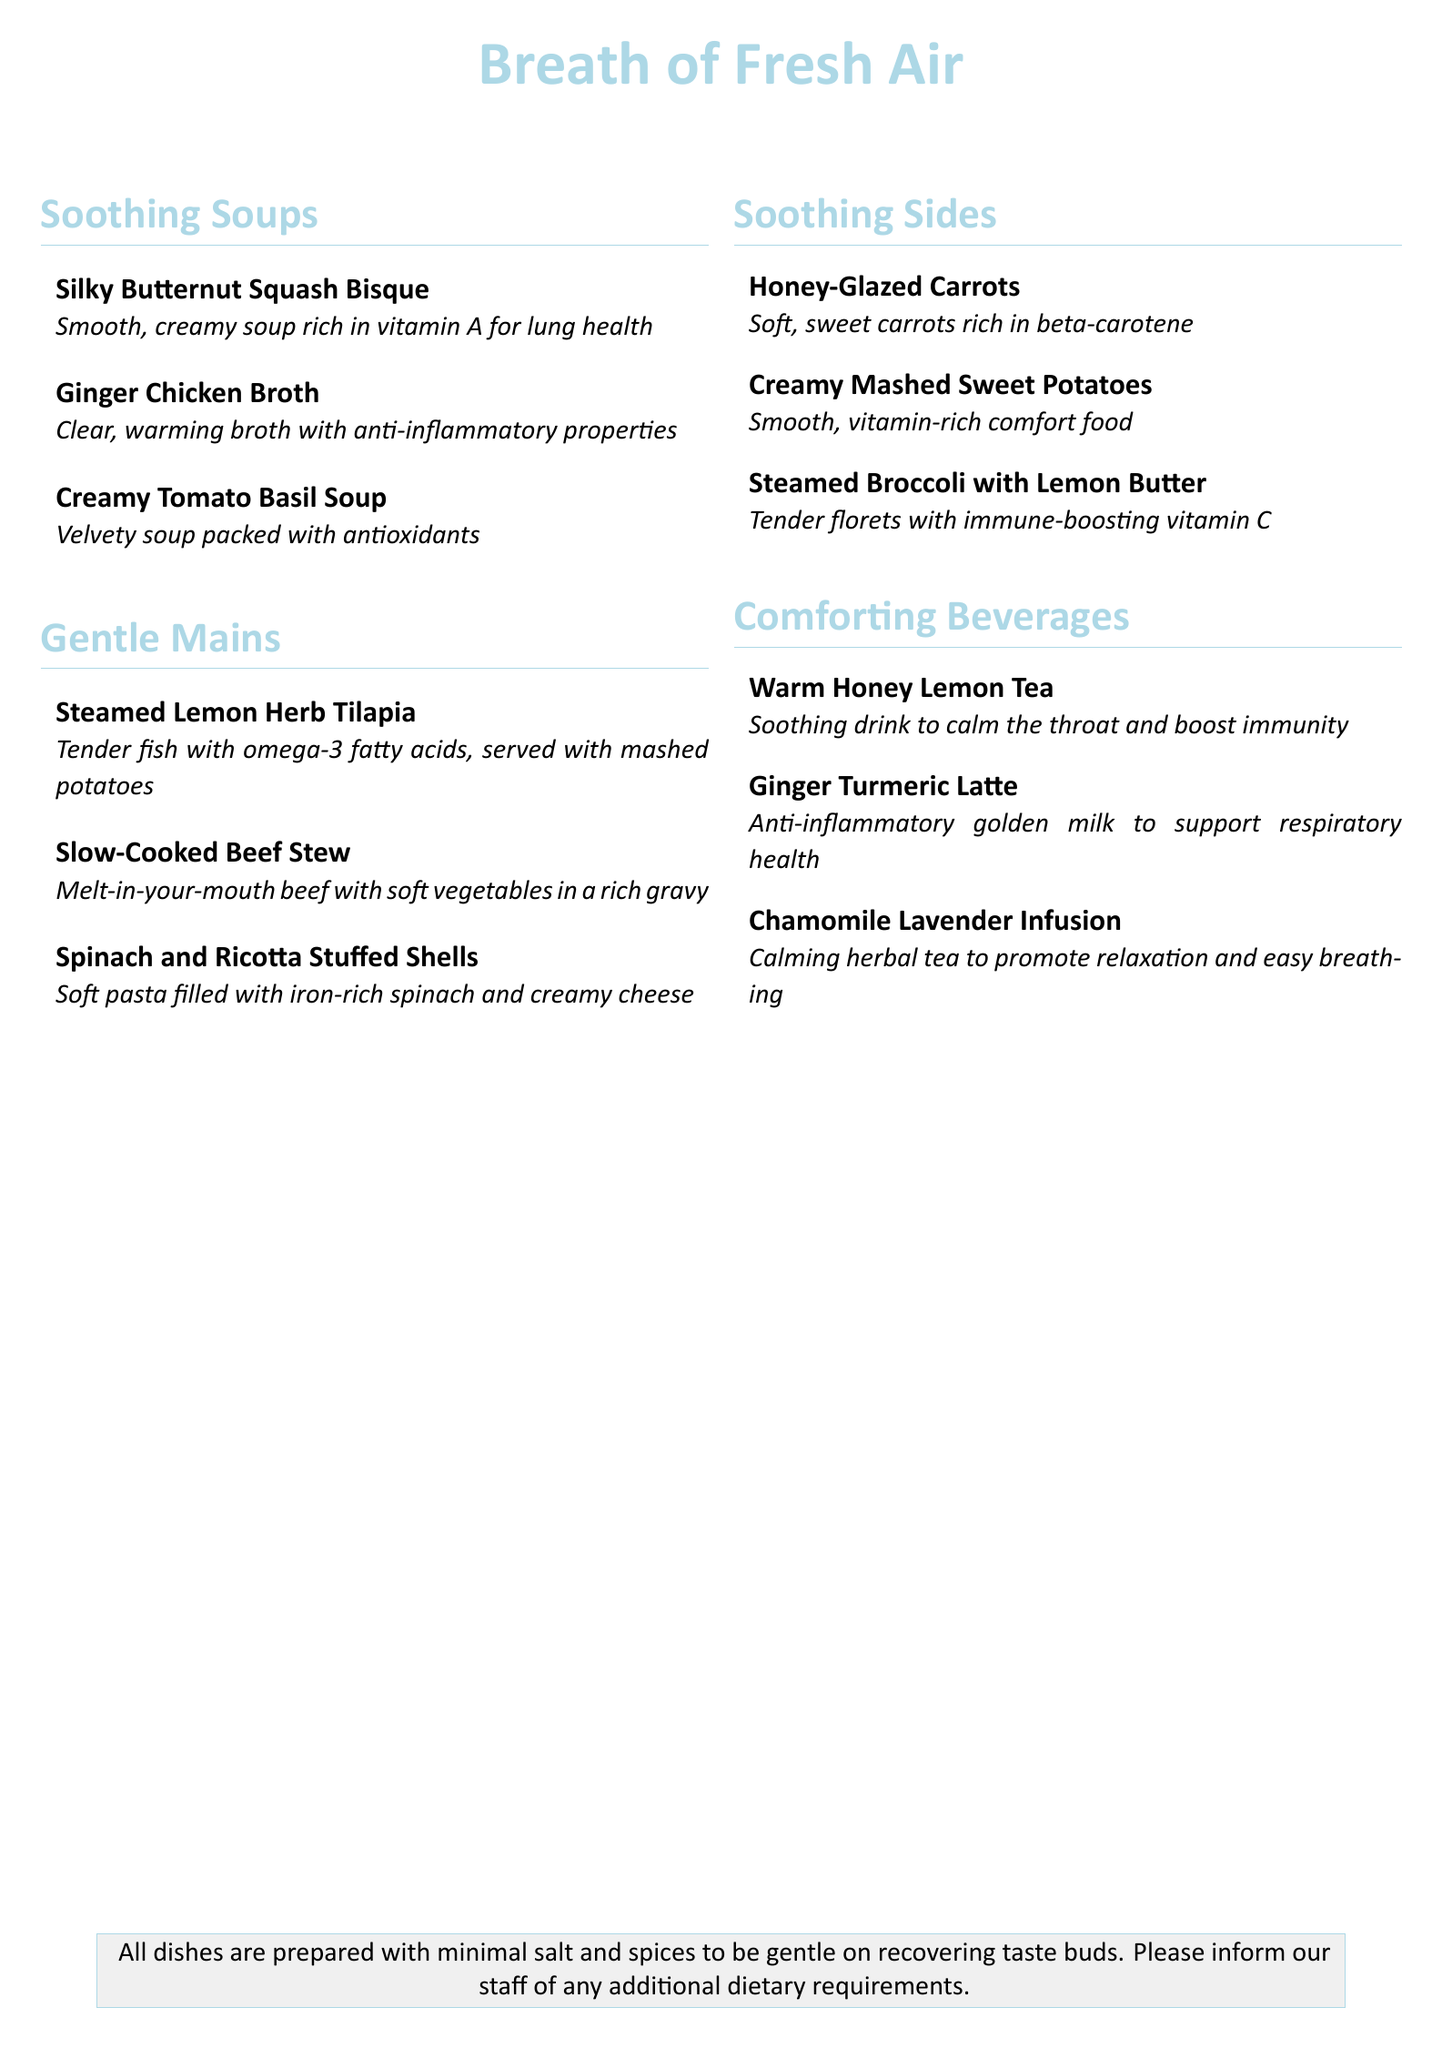What is the name of the soup rich in vitamin A? The name mentioned in the document is "Silky Butternut Squash Bisque," which is noted for its richness in vitamin A for lung health.
Answer: Silky Butternut Squash Bisque Which beverage is described as calming and promotes easy breathing? The beverage that fits this description is "Chamomile Lavender Infusion," which is highlighted for promoting relaxation and easy breathing.
Answer: Chamomile Lavender Infusion How many types of soothing soups are listed? The document lists a total of three types of soothing soups: Silky Butternut Squash Bisque, Ginger Chicken Broth, and Creamy Tomato Basil Soup.
Answer: 3 What is the main ingredient in the Ginger Chicken Broth? The main ingredient is "chicken," and the broth is noted for its anti-inflammatory properties.
Answer: chicken Which dish contains omega-3 fatty acids? The dish that contains omega-3 fatty acids is "Steamed Lemon Herb Tilapia," which is also served with mashed potatoes.
Answer: Steamed Lemon Herb Tilapia What type of potatoes are served as a side dish? The side dish mentioned is "Creamy Mashed Sweet Potatoes," which is described as smooth and vitamin-rich.
Answer: Creamy Mashed Sweet Potatoes Which main dish includes spinach? The main dish that includes spinach is "Spinach and Ricotta Stuffed Shells," which describes soft pasta filled with iron-rich spinach.
Answer: Spinach and Ricotta Stuffed Shells What color is emphasized in the menu title? The color highlighted in the title of the menu is "soft blue," which is consistent throughout sections of the document.
Answer: soft blue 